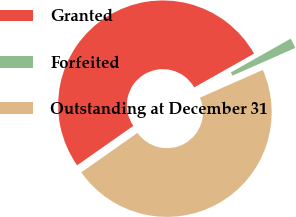<chart> <loc_0><loc_0><loc_500><loc_500><pie_chart><fcel>Granted<fcel>Forfeited<fcel>Outstanding at December 31<nl><fcel>51.55%<fcel>1.58%<fcel>46.86%<nl></chart> 